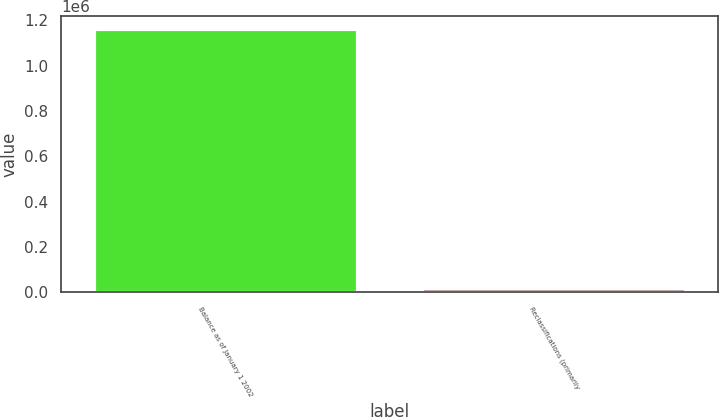Convert chart to OTSL. <chart><loc_0><loc_0><loc_500><loc_500><bar_chart><fcel>Balance as of January 1 2002<fcel>Reclassifications (primarily<nl><fcel>1.16039e+06<fcel>19656<nl></chart> 